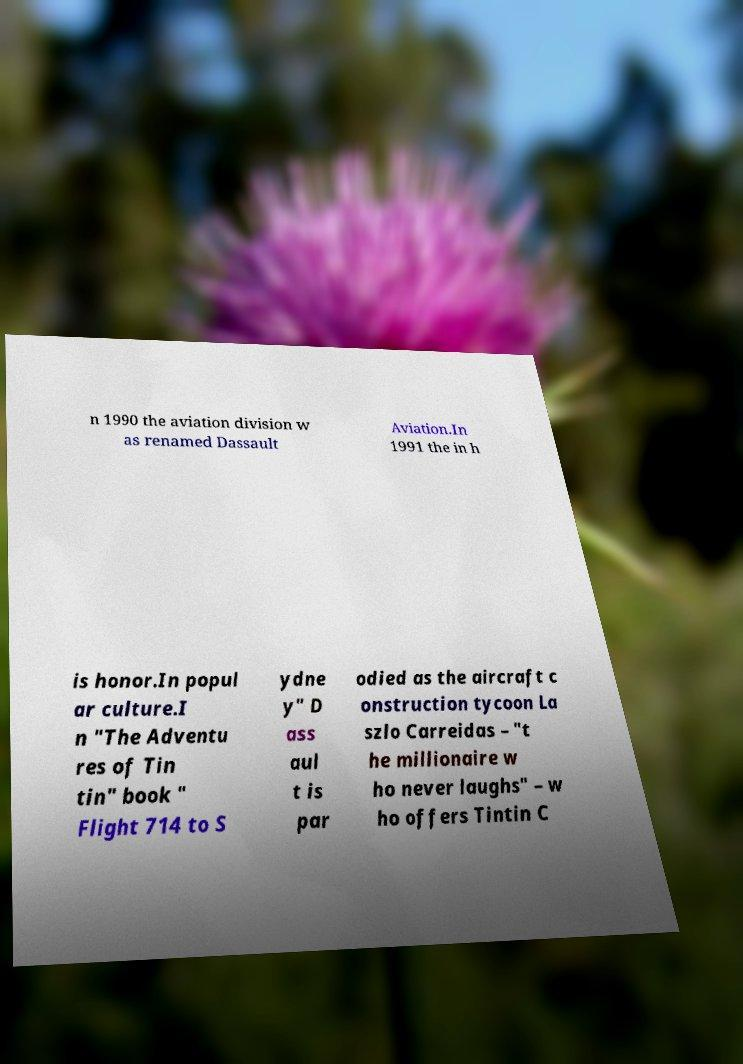Please read and relay the text visible in this image. What does it say? n 1990 the aviation division w as renamed Dassault Aviation.In 1991 the in h is honor.In popul ar culture.I n "The Adventu res of Tin tin" book " Flight 714 to S ydne y" D ass aul t is par odied as the aircraft c onstruction tycoon La szlo Carreidas – "t he millionaire w ho never laughs" – w ho offers Tintin C 